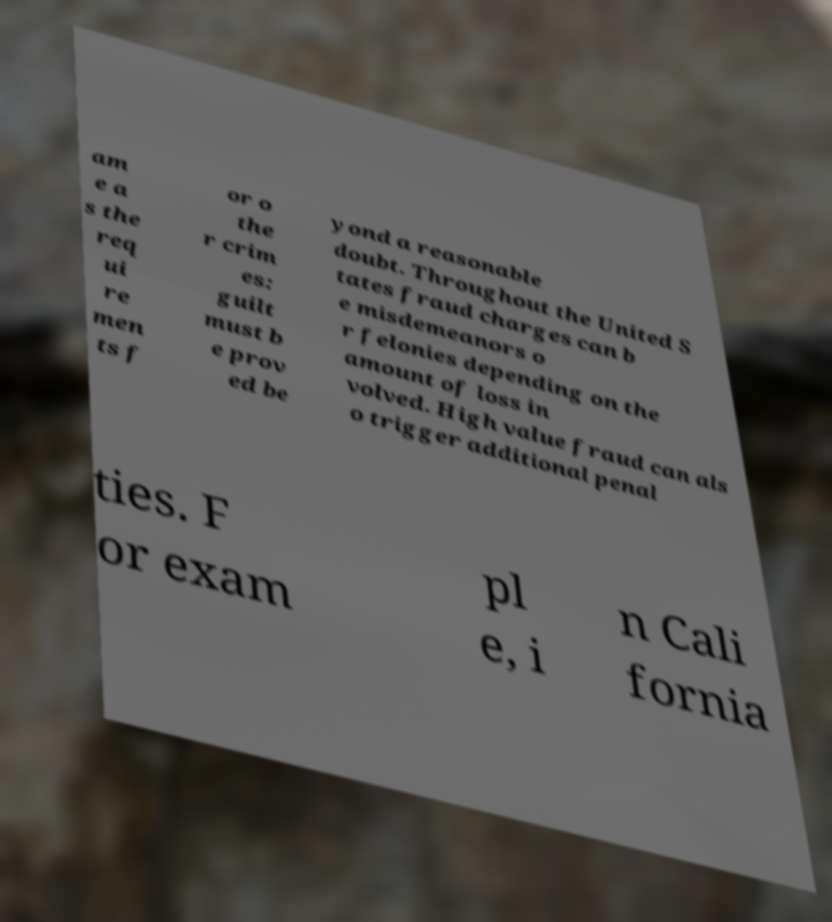Please read and relay the text visible in this image. What does it say? am e a s the req ui re men ts f or o the r crim es: guilt must b e prov ed be yond a reasonable doubt. Throughout the United S tates fraud charges can b e misdemeanors o r felonies depending on the amount of loss in volved. High value fraud can als o trigger additional penal ties. F or exam pl e, i n Cali fornia 